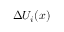Convert formula to latex. <formula><loc_0><loc_0><loc_500><loc_500>\Delta U _ { i } ( x )</formula> 